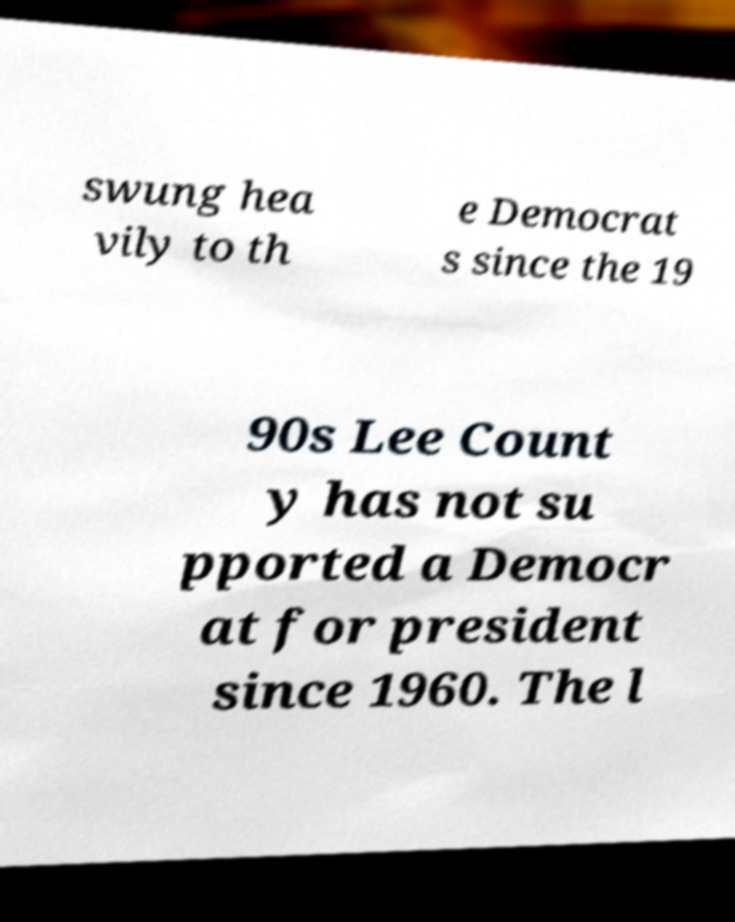Please identify and transcribe the text found in this image. swung hea vily to th e Democrat s since the 19 90s Lee Count y has not su pported a Democr at for president since 1960. The l 